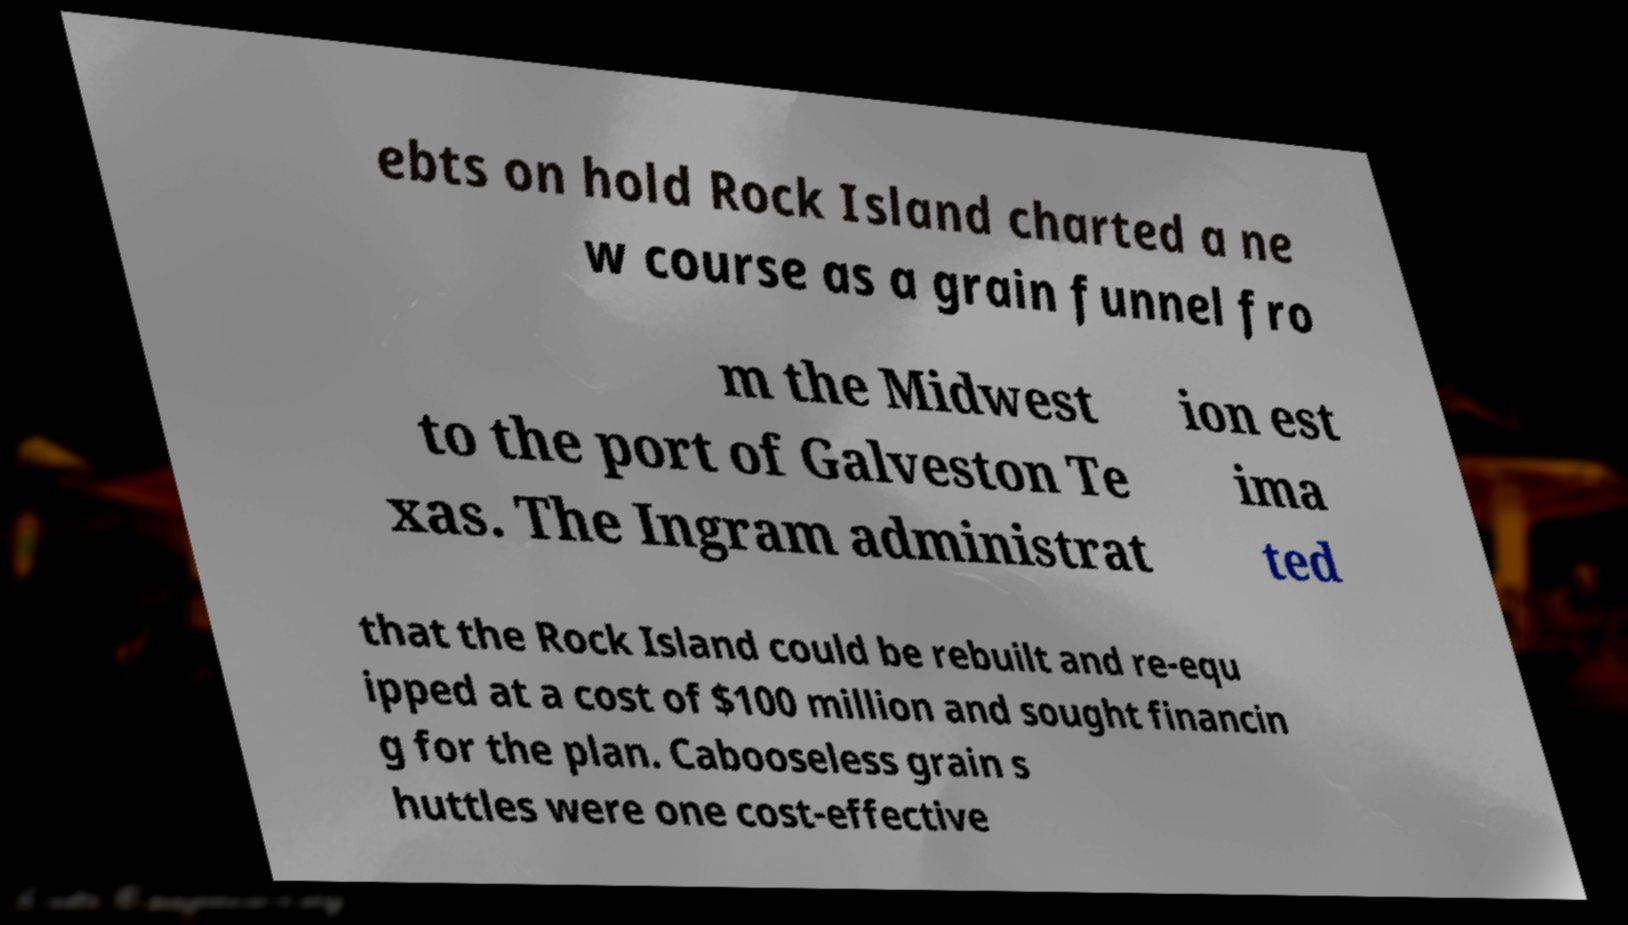Can you read and provide the text displayed in the image?This photo seems to have some interesting text. Can you extract and type it out for me? ebts on hold Rock Island charted a ne w course as a grain funnel fro m the Midwest to the port of Galveston Te xas. The Ingram administrat ion est ima ted that the Rock Island could be rebuilt and re-equ ipped at a cost of $100 million and sought financin g for the plan. Cabooseless grain s huttles were one cost-effective 